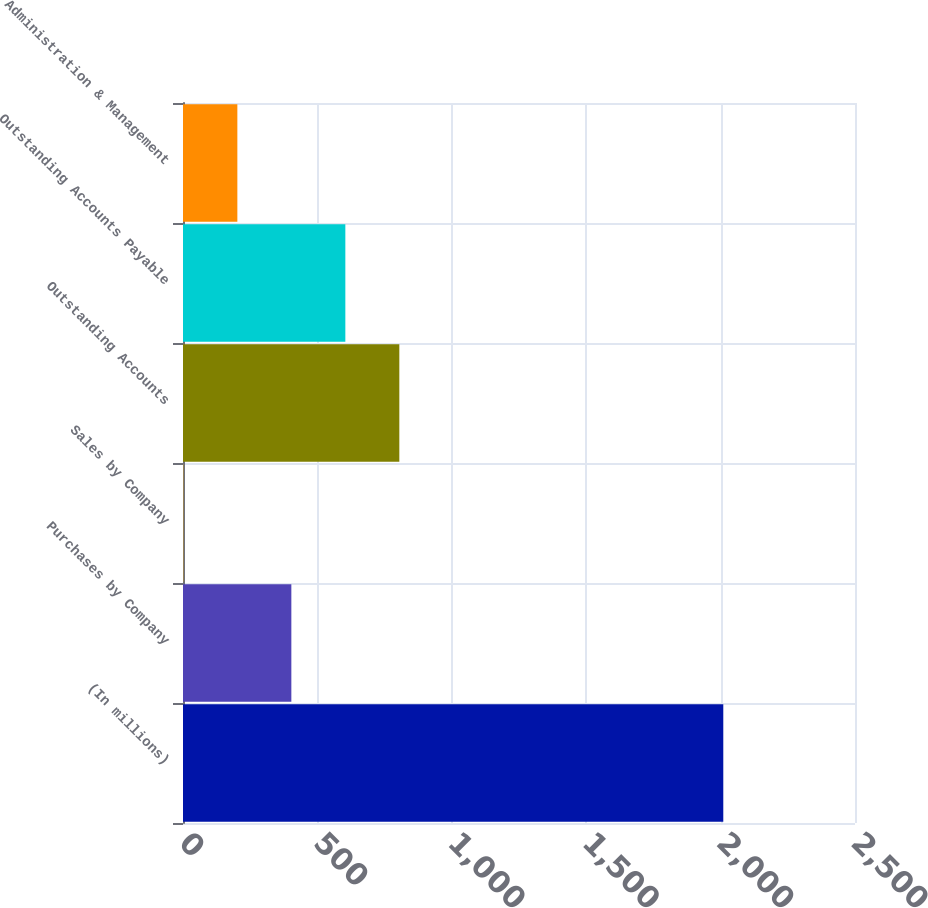Convert chart to OTSL. <chart><loc_0><loc_0><loc_500><loc_500><bar_chart><fcel>(In millions)<fcel>Purchases by Company<fcel>Sales by Company<fcel>Outstanding Accounts<fcel>Outstanding Accounts Payable<fcel>Administration & Management<nl><fcel>2010<fcel>403.08<fcel>1.34<fcel>804.82<fcel>603.95<fcel>202.21<nl></chart> 